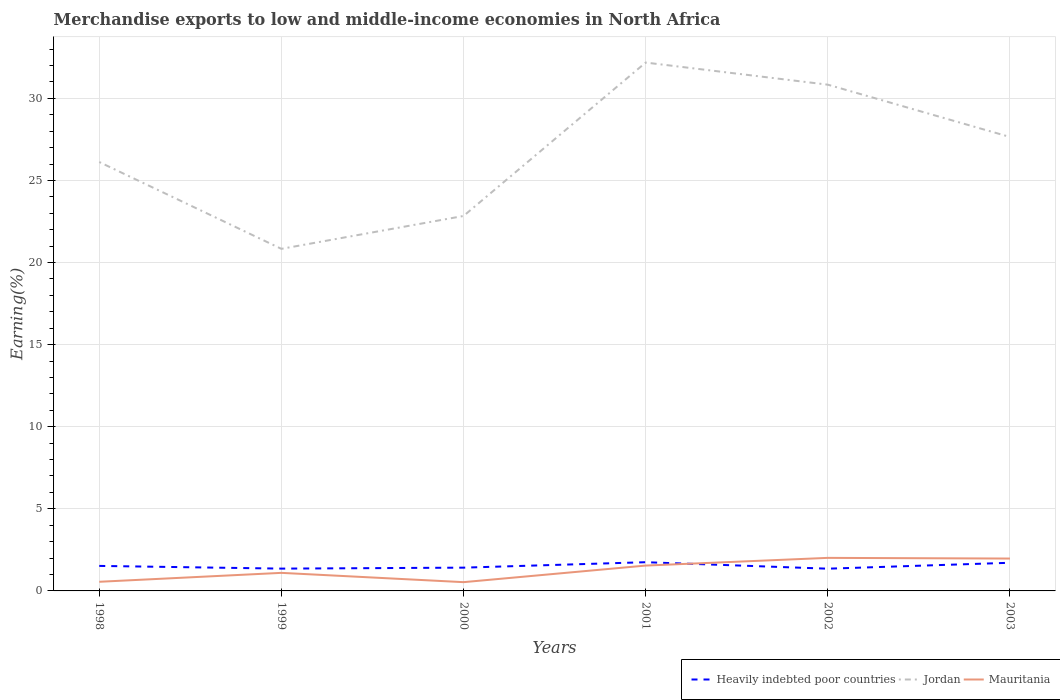Does the line corresponding to Mauritania intersect with the line corresponding to Heavily indebted poor countries?
Your answer should be compact. Yes. Is the number of lines equal to the number of legend labels?
Offer a terse response. Yes. Across all years, what is the maximum percentage of amount earned from merchandise exports in Heavily indebted poor countries?
Ensure brevity in your answer.  1.35. What is the total percentage of amount earned from merchandise exports in Jordan in the graph?
Keep it short and to the point. 3.19. What is the difference between the highest and the second highest percentage of amount earned from merchandise exports in Heavily indebted poor countries?
Offer a very short reply. 0.39. What is the difference between the highest and the lowest percentage of amount earned from merchandise exports in Heavily indebted poor countries?
Provide a short and direct response. 3. Is the percentage of amount earned from merchandise exports in Jordan strictly greater than the percentage of amount earned from merchandise exports in Mauritania over the years?
Your response must be concise. No. How many lines are there?
Your answer should be compact. 3. How many years are there in the graph?
Your answer should be very brief. 6. What is the difference between two consecutive major ticks on the Y-axis?
Ensure brevity in your answer.  5. Does the graph contain grids?
Keep it short and to the point. Yes. Where does the legend appear in the graph?
Offer a very short reply. Bottom right. What is the title of the graph?
Provide a succinct answer. Merchandise exports to low and middle-income economies in North Africa. Does "Guyana" appear as one of the legend labels in the graph?
Provide a succinct answer. No. What is the label or title of the X-axis?
Your answer should be compact. Years. What is the label or title of the Y-axis?
Your response must be concise. Earning(%). What is the Earning(%) of Heavily indebted poor countries in 1998?
Offer a terse response. 1.52. What is the Earning(%) of Jordan in 1998?
Your answer should be compact. 26.12. What is the Earning(%) in Mauritania in 1998?
Provide a succinct answer. 0.56. What is the Earning(%) of Heavily indebted poor countries in 1999?
Give a very brief answer. 1.36. What is the Earning(%) in Jordan in 1999?
Give a very brief answer. 20.83. What is the Earning(%) of Mauritania in 1999?
Keep it short and to the point. 1.1. What is the Earning(%) in Heavily indebted poor countries in 2000?
Offer a very short reply. 1.42. What is the Earning(%) in Jordan in 2000?
Your response must be concise. 22.84. What is the Earning(%) in Mauritania in 2000?
Your response must be concise. 0.53. What is the Earning(%) in Heavily indebted poor countries in 2001?
Give a very brief answer. 1.75. What is the Earning(%) of Jordan in 2001?
Provide a succinct answer. 32.18. What is the Earning(%) in Mauritania in 2001?
Your answer should be very brief. 1.54. What is the Earning(%) in Heavily indebted poor countries in 2002?
Ensure brevity in your answer.  1.35. What is the Earning(%) of Jordan in 2002?
Your response must be concise. 30.83. What is the Earning(%) of Mauritania in 2002?
Keep it short and to the point. 2.01. What is the Earning(%) of Heavily indebted poor countries in 2003?
Your answer should be very brief. 1.71. What is the Earning(%) in Jordan in 2003?
Provide a short and direct response. 27.65. What is the Earning(%) of Mauritania in 2003?
Provide a short and direct response. 1.97. Across all years, what is the maximum Earning(%) of Heavily indebted poor countries?
Your answer should be compact. 1.75. Across all years, what is the maximum Earning(%) in Jordan?
Offer a terse response. 32.18. Across all years, what is the maximum Earning(%) of Mauritania?
Offer a very short reply. 2.01. Across all years, what is the minimum Earning(%) in Heavily indebted poor countries?
Give a very brief answer. 1.35. Across all years, what is the minimum Earning(%) in Jordan?
Keep it short and to the point. 20.83. Across all years, what is the minimum Earning(%) in Mauritania?
Ensure brevity in your answer.  0.53. What is the total Earning(%) of Heavily indebted poor countries in the graph?
Give a very brief answer. 9.12. What is the total Earning(%) in Jordan in the graph?
Keep it short and to the point. 160.45. What is the total Earning(%) in Mauritania in the graph?
Provide a succinct answer. 7.72. What is the difference between the Earning(%) in Heavily indebted poor countries in 1998 and that in 1999?
Your answer should be compact. 0.16. What is the difference between the Earning(%) in Jordan in 1998 and that in 1999?
Give a very brief answer. 5.29. What is the difference between the Earning(%) in Mauritania in 1998 and that in 1999?
Your response must be concise. -0.54. What is the difference between the Earning(%) of Heavily indebted poor countries in 1998 and that in 2000?
Ensure brevity in your answer.  0.11. What is the difference between the Earning(%) of Jordan in 1998 and that in 2000?
Ensure brevity in your answer.  3.29. What is the difference between the Earning(%) in Mauritania in 1998 and that in 2000?
Your answer should be compact. 0.02. What is the difference between the Earning(%) of Heavily indebted poor countries in 1998 and that in 2001?
Offer a very short reply. -0.23. What is the difference between the Earning(%) in Jordan in 1998 and that in 2001?
Provide a succinct answer. -6.06. What is the difference between the Earning(%) in Mauritania in 1998 and that in 2001?
Offer a very short reply. -0.99. What is the difference between the Earning(%) of Heavily indebted poor countries in 1998 and that in 2002?
Keep it short and to the point. 0.17. What is the difference between the Earning(%) of Jordan in 1998 and that in 2002?
Your answer should be very brief. -4.71. What is the difference between the Earning(%) in Mauritania in 1998 and that in 2002?
Keep it short and to the point. -1.46. What is the difference between the Earning(%) of Heavily indebted poor countries in 1998 and that in 2003?
Your response must be concise. -0.19. What is the difference between the Earning(%) of Jordan in 1998 and that in 2003?
Your response must be concise. -1.52. What is the difference between the Earning(%) of Mauritania in 1998 and that in 2003?
Offer a very short reply. -1.41. What is the difference between the Earning(%) of Heavily indebted poor countries in 1999 and that in 2000?
Your answer should be very brief. -0.06. What is the difference between the Earning(%) of Jordan in 1999 and that in 2000?
Make the answer very short. -2. What is the difference between the Earning(%) in Mauritania in 1999 and that in 2000?
Provide a succinct answer. 0.57. What is the difference between the Earning(%) in Heavily indebted poor countries in 1999 and that in 2001?
Provide a succinct answer. -0.39. What is the difference between the Earning(%) of Jordan in 1999 and that in 2001?
Offer a very short reply. -11.35. What is the difference between the Earning(%) of Mauritania in 1999 and that in 2001?
Provide a succinct answer. -0.44. What is the difference between the Earning(%) of Heavily indebted poor countries in 1999 and that in 2002?
Your answer should be very brief. 0. What is the difference between the Earning(%) of Jordan in 1999 and that in 2002?
Make the answer very short. -10. What is the difference between the Earning(%) in Mauritania in 1999 and that in 2002?
Your response must be concise. -0.91. What is the difference between the Earning(%) of Heavily indebted poor countries in 1999 and that in 2003?
Offer a very short reply. -0.36. What is the difference between the Earning(%) in Jordan in 1999 and that in 2003?
Provide a succinct answer. -6.81. What is the difference between the Earning(%) of Mauritania in 1999 and that in 2003?
Offer a very short reply. -0.87. What is the difference between the Earning(%) of Heavily indebted poor countries in 2000 and that in 2001?
Provide a short and direct response. -0.33. What is the difference between the Earning(%) in Jordan in 2000 and that in 2001?
Provide a succinct answer. -9.34. What is the difference between the Earning(%) in Mauritania in 2000 and that in 2001?
Keep it short and to the point. -1.01. What is the difference between the Earning(%) of Heavily indebted poor countries in 2000 and that in 2002?
Your answer should be compact. 0.06. What is the difference between the Earning(%) in Jordan in 2000 and that in 2002?
Offer a very short reply. -8. What is the difference between the Earning(%) in Mauritania in 2000 and that in 2002?
Ensure brevity in your answer.  -1.48. What is the difference between the Earning(%) in Heavily indebted poor countries in 2000 and that in 2003?
Provide a short and direct response. -0.3. What is the difference between the Earning(%) of Jordan in 2000 and that in 2003?
Your response must be concise. -4.81. What is the difference between the Earning(%) of Mauritania in 2000 and that in 2003?
Your answer should be compact. -1.44. What is the difference between the Earning(%) in Heavily indebted poor countries in 2001 and that in 2002?
Your response must be concise. 0.4. What is the difference between the Earning(%) of Jordan in 2001 and that in 2002?
Give a very brief answer. 1.35. What is the difference between the Earning(%) of Mauritania in 2001 and that in 2002?
Keep it short and to the point. -0.47. What is the difference between the Earning(%) of Heavily indebted poor countries in 2001 and that in 2003?
Make the answer very short. 0.03. What is the difference between the Earning(%) in Jordan in 2001 and that in 2003?
Your answer should be compact. 4.53. What is the difference between the Earning(%) of Mauritania in 2001 and that in 2003?
Keep it short and to the point. -0.43. What is the difference between the Earning(%) in Heavily indebted poor countries in 2002 and that in 2003?
Your answer should be very brief. -0.36. What is the difference between the Earning(%) in Jordan in 2002 and that in 2003?
Your answer should be very brief. 3.19. What is the difference between the Earning(%) of Mauritania in 2002 and that in 2003?
Ensure brevity in your answer.  0.04. What is the difference between the Earning(%) of Heavily indebted poor countries in 1998 and the Earning(%) of Jordan in 1999?
Give a very brief answer. -19.31. What is the difference between the Earning(%) in Heavily indebted poor countries in 1998 and the Earning(%) in Mauritania in 1999?
Make the answer very short. 0.42. What is the difference between the Earning(%) in Jordan in 1998 and the Earning(%) in Mauritania in 1999?
Offer a very short reply. 25.02. What is the difference between the Earning(%) in Heavily indebted poor countries in 1998 and the Earning(%) in Jordan in 2000?
Ensure brevity in your answer.  -21.31. What is the difference between the Earning(%) in Heavily indebted poor countries in 1998 and the Earning(%) in Mauritania in 2000?
Make the answer very short. 0.99. What is the difference between the Earning(%) in Jordan in 1998 and the Earning(%) in Mauritania in 2000?
Ensure brevity in your answer.  25.59. What is the difference between the Earning(%) of Heavily indebted poor countries in 1998 and the Earning(%) of Jordan in 2001?
Make the answer very short. -30.66. What is the difference between the Earning(%) of Heavily indebted poor countries in 1998 and the Earning(%) of Mauritania in 2001?
Provide a succinct answer. -0.02. What is the difference between the Earning(%) of Jordan in 1998 and the Earning(%) of Mauritania in 2001?
Your answer should be very brief. 24.58. What is the difference between the Earning(%) in Heavily indebted poor countries in 1998 and the Earning(%) in Jordan in 2002?
Offer a very short reply. -29.31. What is the difference between the Earning(%) of Heavily indebted poor countries in 1998 and the Earning(%) of Mauritania in 2002?
Provide a succinct answer. -0.49. What is the difference between the Earning(%) in Jordan in 1998 and the Earning(%) in Mauritania in 2002?
Make the answer very short. 24.11. What is the difference between the Earning(%) in Heavily indebted poor countries in 1998 and the Earning(%) in Jordan in 2003?
Offer a very short reply. -26.12. What is the difference between the Earning(%) in Heavily indebted poor countries in 1998 and the Earning(%) in Mauritania in 2003?
Give a very brief answer. -0.45. What is the difference between the Earning(%) of Jordan in 1998 and the Earning(%) of Mauritania in 2003?
Your response must be concise. 24.15. What is the difference between the Earning(%) of Heavily indebted poor countries in 1999 and the Earning(%) of Jordan in 2000?
Provide a short and direct response. -21.48. What is the difference between the Earning(%) in Heavily indebted poor countries in 1999 and the Earning(%) in Mauritania in 2000?
Your response must be concise. 0.82. What is the difference between the Earning(%) of Jordan in 1999 and the Earning(%) of Mauritania in 2000?
Keep it short and to the point. 20.3. What is the difference between the Earning(%) of Heavily indebted poor countries in 1999 and the Earning(%) of Jordan in 2001?
Your response must be concise. -30.82. What is the difference between the Earning(%) in Heavily indebted poor countries in 1999 and the Earning(%) in Mauritania in 2001?
Your answer should be compact. -0.19. What is the difference between the Earning(%) in Jordan in 1999 and the Earning(%) in Mauritania in 2001?
Provide a short and direct response. 19.29. What is the difference between the Earning(%) in Heavily indebted poor countries in 1999 and the Earning(%) in Jordan in 2002?
Make the answer very short. -29.47. What is the difference between the Earning(%) in Heavily indebted poor countries in 1999 and the Earning(%) in Mauritania in 2002?
Offer a terse response. -0.65. What is the difference between the Earning(%) in Jordan in 1999 and the Earning(%) in Mauritania in 2002?
Your response must be concise. 18.82. What is the difference between the Earning(%) of Heavily indebted poor countries in 1999 and the Earning(%) of Jordan in 2003?
Your response must be concise. -26.29. What is the difference between the Earning(%) of Heavily indebted poor countries in 1999 and the Earning(%) of Mauritania in 2003?
Keep it short and to the point. -0.61. What is the difference between the Earning(%) in Jordan in 1999 and the Earning(%) in Mauritania in 2003?
Offer a terse response. 18.86. What is the difference between the Earning(%) in Heavily indebted poor countries in 2000 and the Earning(%) in Jordan in 2001?
Give a very brief answer. -30.76. What is the difference between the Earning(%) in Heavily indebted poor countries in 2000 and the Earning(%) in Mauritania in 2001?
Offer a very short reply. -0.13. What is the difference between the Earning(%) in Jordan in 2000 and the Earning(%) in Mauritania in 2001?
Your answer should be very brief. 21.29. What is the difference between the Earning(%) in Heavily indebted poor countries in 2000 and the Earning(%) in Jordan in 2002?
Keep it short and to the point. -29.41. What is the difference between the Earning(%) in Heavily indebted poor countries in 2000 and the Earning(%) in Mauritania in 2002?
Give a very brief answer. -0.6. What is the difference between the Earning(%) in Jordan in 2000 and the Earning(%) in Mauritania in 2002?
Offer a very short reply. 20.82. What is the difference between the Earning(%) in Heavily indebted poor countries in 2000 and the Earning(%) in Jordan in 2003?
Your response must be concise. -26.23. What is the difference between the Earning(%) in Heavily indebted poor countries in 2000 and the Earning(%) in Mauritania in 2003?
Make the answer very short. -0.55. What is the difference between the Earning(%) of Jordan in 2000 and the Earning(%) of Mauritania in 2003?
Provide a short and direct response. 20.86. What is the difference between the Earning(%) in Heavily indebted poor countries in 2001 and the Earning(%) in Jordan in 2002?
Provide a short and direct response. -29.08. What is the difference between the Earning(%) of Heavily indebted poor countries in 2001 and the Earning(%) of Mauritania in 2002?
Offer a terse response. -0.26. What is the difference between the Earning(%) in Jordan in 2001 and the Earning(%) in Mauritania in 2002?
Provide a succinct answer. 30.17. What is the difference between the Earning(%) in Heavily indebted poor countries in 2001 and the Earning(%) in Jordan in 2003?
Provide a succinct answer. -25.9. What is the difference between the Earning(%) of Heavily indebted poor countries in 2001 and the Earning(%) of Mauritania in 2003?
Make the answer very short. -0.22. What is the difference between the Earning(%) in Jordan in 2001 and the Earning(%) in Mauritania in 2003?
Give a very brief answer. 30.21. What is the difference between the Earning(%) of Heavily indebted poor countries in 2002 and the Earning(%) of Jordan in 2003?
Provide a short and direct response. -26.29. What is the difference between the Earning(%) of Heavily indebted poor countries in 2002 and the Earning(%) of Mauritania in 2003?
Offer a terse response. -0.62. What is the difference between the Earning(%) in Jordan in 2002 and the Earning(%) in Mauritania in 2003?
Provide a succinct answer. 28.86. What is the average Earning(%) in Heavily indebted poor countries per year?
Provide a short and direct response. 1.52. What is the average Earning(%) of Jordan per year?
Provide a succinct answer. 26.74. What is the average Earning(%) of Mauritania per year?
Offer a very short reply. 1.29. In the year 1998, what is the difference between the Earning(%) in Heavily indebted poor countries and Earning(%) in Jordan?
Provide a short and direct response. -24.6. In the year 1998, what is the difference between the Earning(%) of Heavily indebted poor countries and Earning(%) of Mauritania?
Offer a very short reply. 0.97. In the year 1998, what is the difference between the Earning(%) in Jordan and Earning(%) in Mauritania?
Give a very brief answer. 25.57. In the year 1999, what is the difference between the Earning(%) in Heavily indebted poor countries and Earning(%) in Jordan?
Offer a very short reply. -19.47. In the year 1999, what is the difference between the Earning(%) in Heavily indebted poor countries and Earning(%) in Mauritania?
Make the answer very short. 0.26. In the year 1999, what is the difference between the Earning(%) in Jordan and Earning(%) in Mauritania?
Provide a succinct answer. 19.73. In the year 2000, what is the difference between the Earning(%) of Heavily indebted poor countries and Earning(%) of Jordan?
Provide a short and direct response. -21.42. In the year 2000, what is the difference between the Earning(%) in Heavily indebted poor countries and Earning(%) in Mauritania?
Ensure brevity in your answer.  0.88. In the year 2000, what is the difference between the Earning(%) in Jordan and Earning(%) in Mauritania?
Make the answer very short. 22.3. In the year 2001, what is the difference between the Earning(%) of Heavily indebted poor countries and Earning(%) of Jordan?
Keep it short and to the point. -30.43. In the year 2001, what is the difference between the Earning(%) in Heavily indebted poor countries and Earning(%) in Mauritania?
Your answer should be very brief. 0.21. In the year 2001, what is the difference between the Earning(%) of Jordan and Earning(%) of Mauritania?
Make the answer very short. 30.63. In the year 2002, what is the difference between the Earning(%) in Heavily indebted poor countries and Earning(%) in Jordan?
Ensure brevity in your answer.  -29.48. In the year 2002, what is the difference between the Earning(%) in Heavily indebted poor countries and Earning(%) in Mauritania?
Your response must be concise. -0.66. In the year 2002, what is the difference between the Earning(%) in Jordan and Earning(%) in Mauritania?
Make the answer very short. 28.82. In the year 2003, what is the difference between the Earning(%) of Heavily indebted poor countries and Earning(%) of Jordan?
Offer a very short reply. -25.93. In the year 2003, what is the difference between the Earning(%) of Heavily indebted poor countries and Earning(%) of Mauritania?
Keep it short and to the point. -0.26. In the year 2003, what is the difference between the Earning(%) of Jordan and Earning(%) of Mauritania?
Make the answer very short. 25.68. What is the ratio of the Earning(%) of Heavily indebted poor countries in 1998 to that in 1999?
Your answer should be compact. 1.12. What is the ratio of the Earning(%) in Jordan in 1998 to that in 1999?
Offer a very short reply. 1.25. What is the ratio of the Earning(%) in Mauritania in 1998 to that in 1999?
Provide a short and direct response. 0.51. What is the ratio of the Earning(%) of Heavily indebted poor countries in 1998 to that in 2000?
Ensure brevity in your answer.  1.07. What is the ratio of the Earning(%) of Jordan in 1998 to that in 2000?
Offer a terse response. 1.14. What is the ratio of the Earning(%) of Mauritania in 1998 to that in 2000?
Ensure brevity in your answer.  1.04. What is the ratio of the Earning(%) in Heavily indebted poor countries in 1998 to that in 2001?
Keep it short and to the point. 0.87. What is the ratio of the Earning(%) in Jordan in 1998 to that in 2001?
Your response must be concise. 0.81. What is the ratio of the Earning(%) of Mauritania in 1998 to that in 2001?
Provide a succinct answer. 0.36. What is the ratio of the Earning(%) of Heavily indebted poor countries in 1998 to that in 2002?
Your answer should be compact. 1.13. What is the ratio of the Earning(%) in Jordan in 1998 to that in 2002?
Ensure brevity in your answer.  0.85. What is the ratio of the Earning(%) of Mauritania in 1998 to that in 2002?
Provide a short and direct response. 0.28. What is the ratio of the Earning(%) of Heavily indebted poor countries in 1998 to that in 2003?
Your answer should be very brief. 0.89. What is the ratio of the Earning(%) of Jordan in 1998 to that in 2003?
Offer a terse response. 0.94. What is the ratio of the Earning(%) in Mauritania in 1998 to that in 2003?
Your answer should be compact. 0.28. What is the ratio of the Earning(%) of Heavily indebted poor countries in 1999 to that in 2000?
Offer a terse response. 0.96. What is the ratio of the Earning(%) of Jordan in 1999 to that in 2000?
Your answer should be compact. 0.91. What is the ratio of the Earning(%) in Mauritania in 1999 to that in 2000?
Provide a short and direct response. 2.06. What is the ratio of the Earning(%) in Heavily indebted poor countries in 1999 to that in 2001?
Your response must be concise. 0.78. What is the ratio of the Earning(%) in Jordan in 1999 to that in 2001?
Ensure brevity in your answer.  0.65. What is the ratio of the Earning(%) in Mauritania in 1999 to that in 2001?
Provide a short and direct response. 0.71. What is the ratio of the Earning(%) in Heavily indebted poor countries in 1999 to that in 2002?
Your answer should be very brief. 1. What is the ratio of the Earning(%) of Jordan in 1999 to that in 2002?
Give a very brief answer. 0.68. What is the ratio of the Earning(%) in Mauritania in 1999 to that in 2002?
Provide a short and direct response. 0.55. What is the ratio of the Earning(%) of Heavily indebted poor countries in 1999 to that in 2003?
Make the answer very short. 0.79. What is the ratio of the Earning(%) of Jordan in 1999 to that in 2003?
Offer a very short reply. 0.75. What is the ratio of the Earning(%) in Mauritania in 1999 to that in 2003?
Make the answer very short. 0.56. What is the ratio of the Earning(%) of Heavily indebted poor countries in 2000 to that in 2001?
Your answer should be very brief. 0.81. What is the ratio of the Earning(%) in Jordan in 2000 to that in 2001?
Give a very brief answer. 0.71. What is the ratio of the Earning(%) of Mauritania in 2000 to that in 2001?
Your response must be concise. 0.35. What is the ratio of the Earning(%) in Heavily indebted poor countries in 2000 to that in 2002?
Ensure brevity in your answer.  1.05. What is the ratio of the Earning(%) in Jordan in 2000 to that in 2002?
Ensure brevity in your answer.  0.74. What is the ratio of the Earning(%) in Mauritania in 2000 to that in 2002?
Keep it short and to the point. 0.27. What is the ratio of the Earning(%) of Heavily indebted poor countries in 2000 to that in 2003?
Your answer should be very brief. 0.83. What is the ratio of the Earning(%) in Jordan in 2000 to that in 2003?
Provide a succinct answer. 0.83. What is the ratio of the Earning(%) of Mauritania in 2000 to that in 2003?
Ensure brevity in your answer.  0.27. What is the ratio of the Earning(%) in Heavily indebted poor countries in 2001 to that in 2002?
Your answer should be very brief. 1.29. What is the ratio of the Earning(%) of Jordan in 2001 to that in 2002?
Ensure brevity in your answer.  1.04. What is the ratio of the Earning(%) in Mauritania in 2001 to that in 2002?
Your answer should be very brief. 0.77. What is the ratio of the Earning(%) of Heavily indebted poor countries in 2001 to that in 2003?
Provide a short and direct response. 1.02. What is the ratio of the Earning(%) of Jordan in 2001 to that in 2003?
Your answer should be compact. 1.16. What is the ratio of the Earning(%) of Mauritania in 2001 to that in 2003?
Make the answer very short. 0.78. What is the ratio of the Earning(%) of Heavily indebted poor countries in 2002 to that in 2003?
Offer a very short reply. 0.79. What is the ratio of the Earning(%) of Jordan in 2002 to that in 2003?
Your response must be concise. 1.12. What is the ratio of the Earning(%) in Mauritania in 2002 to that in 2003?
Your answer should be compact. 1.02. What is the difference between the highest and the second highest Earning(%) in Heavily indebted poor countries?
Make the answer very short. 0.03. What is the difference between the highest and the second highest Earning(%) of Jordan?
Keep it short and to the point. 1.35. What is the difference between the highest and the second highest Earning(%) of Mauritania?
Provide a succinct answer. 0.04. What is the difference between the highest and the lowest Earning(%) in Heavily indebted poor countries?
Make the answer very short. 0.4. What is the difference between the highest and the lowest Earning(%) of Jordan?
Your response must be concise. 11.35. What is the difference between the highest and the lowest Earning(%) in Mauritania?
Ensure brevity in your answer.  1.48. 